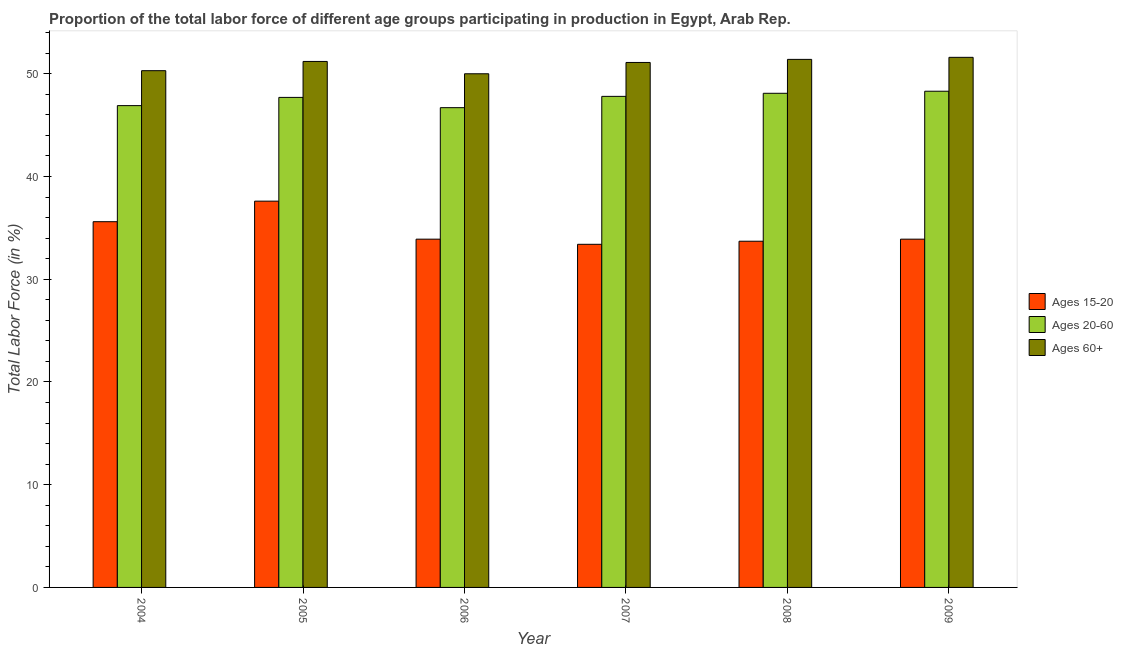How many different coloured bars are there?
Offer a very short reply. 3. How many groups of bars are there?
Your answer should be compact. 6. What is the label of the 2nd group of bars from the left?
Your answer should be very brief. 2005. What is the percentage of labor force above age 60 in 2009?
Your answer should be very brief. 51.6. Across all years, what is the maximum percentage of labor force above age 60?
Your answer should be very brief. 51.6. Across all years, what is the minimum percentage of labor force within the age group 15-20?
Your answer should be very brief. 33.4. What is the total percentage of labor force within the age group 20-60 in the graph?
Your response must be concise. 285.5. What is the difference between the percentage of labor force within the age group 20-60 in 2004 and that in 2008?
Provide a succinct answer. -1.2. What is the average percentage of labor force within the age group 20-60 per year?
Offer a terse response. 47.58. What is the ratio of the percentage of labor force above age 60 in 2008 to that in 2009?
Provide a succinct answer. 1. Is the percentage of labor force above age 60 in 2007 less than that in 2008?
Ensure brevity in your answer.  Yes. Is the difference between the percentage of labor force within the age group 15-20 in 2004 and 2005 greater than the difference between the percentage of labor force within the age group 20-60 in 2004 and 2005?
Your response must be concise. No. What is the difference between the highest and the lowest percentage of labor force within the age group 20-60?
Give a very brief answer. 1.6. In how many years, is the percentage of labor force within the age group 15-20 greater than the average percentage of labor force within the age group 15-20 taken over all years?
Your answer should be very brief. 2. What does the 1st bar from the left in 2004 represents?
Give a very brief answer. Ages 15-20. What does the 2nd bar from the right in 2009 represents?
Provide a short and direct response. Ages 20-60. Is it the case that in every year, the sum of the percentage of labor force within the age group 15-20 and percentage of labor force within the age group 20-60 is greater than the percentage of labor force above age 60?
Keep it short and to the point. Yes. What is the difference between two consecutive major ticks on the Y-axis?
Ensure brevity in your answer.  10. Are the values on the major ticks of Y-axis written in scientific E-notation?
Ensure brevity in your answer.  No. Does the graph contain any zero values?
Provide a succinct answer. No. Does the graph contain grids?
Give a very brief answer. No. Where does the legend appear in the graph?
Your answer should be very brief. Center right. How many legend labels are there?
Make the answer very short. 3. How are the legend labels stacked?
Your answer should be compact. Vertical. What is the title of the graph?
Offer a terse response. Proportion of the total labor force of different age groups participating in production in Egypt, Arab Rep. Does "Solid fuel" appear as one of the legend labels in the graph?
Give a very brief answer. No. What is the label or title of the X-axis?
Your answer should be very brief. Year. What is the Total Labor Force (in %) of Ages 15-20 in 2004?
Offer a very short reply. 35.6. What is the Total Labor Force (in %) in Ages 20-60 in 2004?
Offer a very short reply. 46.9. What is the Total Labor Force (in %) of Ages 60+ in 2004?
Offer a terse response. 50.3. What is the Total Labor Force (in %) of Ages 15-20 in 2005?
Your response must be concise. 37.6. What is the Total Labor Force (in %) in Ages 20-60 in 2005?
Make the answer very short. 47.7. What is the Total Labor Force (in %) in Ages 60+ in 2005?
Offer a terse response. 51.2. What is the Total Labor Force (in %) in Ages 15-20 in 2006?
Offer a terse response. 33.9. What is the Total Labor Force (in %) of Ages 20-60 in 2006?
Ensure brevity in your answer.  46.7. What is the Total Labor Force (in %) of Ages 15-20 in 2007?
Provide a short and direct response. 33.4. What is the Total Labor Force (in %) in Ages 20-60 in 2007?
Provide a succinct answer. 47.8. What is the Total Labor Force (in %) in Ages 60+ in 2007?
Offer a very short reply. 51.1. What is the Total Labor Force (in %) in Ages 15-20 in 2008?
Give a very brief answer. 33.7. What is the Total Labor Force (in %) in Ages 20-60 in 2008?
Your response must be concise. 48.1. What is the Total Labor Force (in %) in Ages 60+ in 2008?
Provide a short and direct response. 51.4. What is the Total Labor Force (in %) of Ages 15-20 in 2009?
Make the answer very short. 33.9. What is the Total Labor Force (in %) in Ages 20-60 in 2009?
Offer a terse response. 48.3. What is the Total Labor Force (in %) in Ages 60+ in 2009?
Provide a succinct answer. 51.6. Across all years, what is the maximum Total Labor Force (in %) of Ages 15-20?
Offer a very short reply. 37.6. Across all years, what is the maximum Total Labor Force (in %) in Ages 20-60?
Give a very brief answer. 48.3. Across all years, what is the maximum Total Labor Force (in %) of Ages 60+?
Your answer should be very brief. 51.6. Across all years, what is the minimum Total Labor Force (in %) in Ages 15-20?
Ensure brevity in your answer.  33.4. Across all years, what is the minimum Total Labor Force (in %) of Ages 20-60?
Provide a short and direct response. 46.7. Across all years, what is the minimum Total Labor Force (in %) of Ages 60+?
Your answer should be very brief. 50. What is the total Total Labor Force (in %) in Ages 15-20 in the graph?
Your answer should be compact. 208.1. What is the total Total Labor Force (in %) in Ages 20-60 in the graph?
Your response must be concise. 285.5. What is the total Total Labor Force (in %) of Ages 60+ in the graph?
Your response must be concise. 305.6. What is the difference between the Total Labor Force (in %) in Ages 15-20 in 2004 and that in 2005?
Your answer should be compact. -2. What is the difference between the Total Labor Force (in %) of Ages 60+ in 2004 and that in 2006?
Your response must be concise. 0.3. What is the difference between the Total Labor Force (in %) of Ages 20-60 in 2004 and that in 2007?
Your answer should be very brief. -0.9. What is the difference between the Total Labor Force (in %) in Ages 60+ in 2004 and that in 2008?
Offer a very short reply. -1.1. What is the difference between the Total Labor Force (in %) in Ages 15-20 in 2004 and that in 2009?
Your response must be concise. 1.7. What is the difference between the Total Labor Force (in %) in Ages 20-60 in 2004 and that in 2009?
Offer a terse response. -1.4. What is the difference between the Total Labor Force (in %) in Ages 20-60 in 2005 and that in 2006?
Provide a succinct answer. 1. What is the difference between the Total Labor Force (in %) in Ages 60+ in 2005 and that in 2006?
Your answer should be compact. 1.2. What is the difference between the Total Labor Force (in %) in Ages 15-20 in 2005 and that in 2007?
Ensure brevity in your answer.  4.2. What is the difference between the Total Labor Force (in %) in Ages 20-60 in 2005 and that in 2008?
Give a very brief answer. -0.4. What is the difference between the Total Labor Force (in %) in Ages 15-20 in 2006 and that in 2008?
Offer a terse response. 0.2. What is the difference between the Total Labor Force (in %) of Ages 60+ in 2006 and that in 2008?
Offer a terse response. -1.4. What is the difference between the Total Labor Force (in %) in Ages 15-20 in 2006 and that in 2009?
Keep it short and to the point. 0. What is the difference between the Total Labor Force (in %) in Ages 20-60 in 2007 and that in 2009?
Your answer should be very brief. -0.5. What is the difference between the Total Labor Force (in %) of Ages 15-20 in 2008 and that in 2009?
Your response must be concise. -0.2. What is the difference between the Total Labor Force (in %) in Ages 15-20 in 2004 and the Total Labor Force (in %) in Ages 20-60 in 2005?
Keep it short and to the point. -12.1. What is the difference between the Total Labor Force (in %) in Ages 15-20 in 2004 and the Total Labor Force (in %) in Ages 60+ in 2005?
Offer a terse response. -15.6. What is the difference between the Total Labor Force (in %) in Ages 20-60 in 2004 and the Total Labor Force (in %) in Ages 60+ in 2005?
Offer a very short reply. -4.3. What is the difference between the Total Labor Force (in %) in Ages 15-20 in 2004 and the Total Labor Force (in %) in Ages 60+ in 2006?
Keep it short and to the point. -14.4. What is the difference between the Total Labor Force (in %) in Ages 20-60 in 2004 and the Total Labor Force (in %) in Ages 60+ in 2006?
Ensure brevity in your answer.  -3.1. What is the difference between the Total Labor Force (in %) in Ages 15-20 in 2004 and the Total Labor Force (in %) in Ages 20-60 in 2007?
Ensure brevity in your answer.  -12.2. What is the difference between the Total Labor Force (in %) of Ages 15-20 in 2004 and the Total Labor Force (in %) of Ages 60+ in 2007?
Provide a short and direct response. -15.5. What is the difference between the Total Labor Force (in %) in Ages 20-60 in 2004 and the Total Labor Force (in %) in Ages 60+ in 2007?
Provide a succinct answer. -4.2. What is the difference between the Total Labor Force (in %) of Ages 15-20 in 2004 and the Total Labor Force (in %) of Ages 60+ in 2008?
Make the answer very short. -15.8. What is the difference between the Total Labor Force (in %) of Ages 15-20 in 2004 and the Total Labor Force (in %) of Ages 60+ in 2009?
Provide a short and direct response. -16. What is the difference between the Total Labor Force (in %) of Ages 20-60 in 2004 and the Total Labor Force (in %) of Ages 60+ in 2009?
Provide a succinct answer. -4.7. What is the difference between the Total Labor Force (in %) of Ages 20-60 in 2005 and the Total Labor Force (in %) of Ages 60+ in 2006?
Provide a short and direct response. -2.3. What is the difference between the Total Labor Force (in %) of Ages 15-20 in 2005 and the Total Labor Force (in %) of Ages 60+ in 2007?
Ensure brevity in your answer.  -13.5. What is the difference between the Total Labor Force (in %) in Ages 20-60 in 2005 and the Total Labor Force (in %) in Ages 60+ in 2007?
Offer a terse response. -3.4. What is the difference between the Total Labor Force (in %) of Ages 15-20 in 2005 and the Total Labor Force (in %) of Ages 20-60 in 2009?
Your response must be concise. -10.7. What is the difference between the Total Labor Force (in %) of Ages 15-20 in 2006 and the Total Labor Force (in %) of Ages 20-60 in 2007?
Offer a terse response. -13.9. What is the difference between the Total Labor Force (in %) in Ages 15-20 in 2006 and the Total Labor Force (in %) in Ages 60+ in 2007?
Your response must be concise. -17.2. What is the difference between the Total Labor Force (in %) in Ages 20-60 in 2006 and the Total Labor Force (in %) in Ages 60+ in 2007?
Your answer should be compact. -4.4. What is the difference between the Total Labor Force (in %) of Ages 15-20 in 2006 and the Total Labor Force (in %) of Ages 20-60 in 2008?
Make the answer very short. -14.2. What is the difference between the Total Labor Force (in %) of Ages 15-20 in 2006 and the Total Labor Force (in %) of Ages 60+ in 2008?
Make the answer very short. -17.5. What is the difference between the Total Labor Force (in %) in Ages 20-60 in 2006 and the Total Labor Force (in %) in Ages 60+ in 2008?
Offer a very short reply. -4.7. What is the difference between the Total Labor Force (in %) of Ages 15-20 in 2006 and the Total Labor Force (in %) of Ages 20-60 in 2009?
Keep it short and to the point. -14.4. What is the difference between the Total Labor Force (in %) of Ages 15-20 in 2006 and the Total Labor Force (in %) of Ages 60+ in 2009?
Offer a terse response. -17.7. What is the difference between the Total Labor Force (in %) of Ages 15-20 in 2007 and the Total Labor Force (in %) of Ages 20-60 in 2008?
Your response must be concise. -14.7. What is the difference between the Total Labor Force (in %) in Ages 15-20 in 2007 and the Total Labor Force (in %) in Ages 60+ in 2008?
Give a very brief answer. -18. What is the difference between the Total Labor Force (in %) in Ages 15-20 in 2007 and the Total Labor Force (in %) in Ages 20-60 in 2009?
Provide a succinct answer. -14.9. What is the difference between the Total Labor Force (in %) in Ages 15-20 in 2007 and the Total Labor Force (in %) in Ages 60+ in 2009?
Provide a succinct answer. -18.2. What is the difference between the Total Labor Force (in %) of Ages 15-20 in 2008 and the Total Labor Force (in %) of Ages 20-60 in 2009?
Ensure brevity in your answer.  -14.6. What is the difference between the Total Labor Force (in %) in Ages 15-20 in 2008 and the Total Labor Force (in %) in Ages 60+ in 2009?
Give a very brief answer. -17.9. What is the average Total Labor Force (in %) of Ages 15-20 per year?
Keep it short and to the point. 34.68. What is the average Total Labor Force (in %) of Ages 20-60 per year?
Make the answer very short. 47.58. What is the average Total Labor Force (in %) in Ages 60+ per year?
Make the answer very short. 50.93. In the year 2004, what is the difference between the Total Labor Force (in %) of Ages 15-20 and Total Labor Force (in %) of Ages 60+?
Offer a terse response. -14.7. In the year 2004, what is the difference between the Total Labor Force (in %) of Ages 20-60 and Total Labor Force (in %) of Ages 60+?
Your answer should be compact. -3.4. In the year 2005, what is the difference between the Total Labor Force (in %) of Ages 20-60 and Total Labor Force (in %) of Ages 60+?
Make the answer very short. -3.5. In the year 2006, what is the difference between the Total Labor Force (in %) in Ages 15-20 and Total Labor Force (in %) in Ages 60+?
Provide a succinct answer. -16.1. In the year 2006, what is the difference between the Total Labor Force (in %) in Ages 20-60 and Total Labor Force (in %) in Ages 60+?
Ensure brevity in your answer.  -3.3. In the year 2007, what is the difference between the Total Labor Force (in %) of Ages 15-20 and Total Labor Force (in %) of Ages 20-60?
Provide a succinct answer. -14.4. In the year 2007, what is the difference between the Total Labor Force (in %) in Ages 15-20 and Total Labor Force (in %) in Ages 60+?
Provide a short and direct response. -17.7. In the year 2008, what is the difference between the Total Labor Force (in %) of Ages 15-20 and Total Labor Force (in %) of Ages 20-60?
Provide a short and direct response. -14.4. In the year 2008, what is the difference between the Total Labor Force (in %) of Ages 15-20 and Total Labor Force (in %) of Ages 60+?
Your answer should be compact. -17.7. In the year 2008, what is the difference between the Total Labor Force (in %) in Ages 20-60 and Total Labor Force (in %) in Ages 60+?
Give a very brief answer. -3.3. In the year 2009, what is the difference between the Total Labor Force (in %) in Ages 15-20 and Total Labor Force (in %) in Ages 20-60?
Your answer should be compact. -14.4. In the year 2009, what is the difference between the Total Labor Force (in %) of Ages 15-20 and Total Labor Force (in %) of Ages 60+?
Offer a terse response. -17.7. In the year 2009, what is the difference between the Total Labor Force (in %) of Ages 20-60 and Total Labor Force (in %) of Ages 60+?
Your response must be concise. -3.3. What is the ratio of the Total Labor Force (in %) in Ages 15-20 in 2004 to that in 2005?
Your answer should be very brief. 0.95. What is the ratio of the Total Labor Force (in %) of Ages 20-60 in 2004 to that in 2005?
Offer a very short reply. 0.98. What is the ratio of the Total Labor Force (in %) of Ages 60+ in 2004 to that in 2005?
Make the answer very short. 0.98. What is the ratio of the Total Labor Force (in %) in Ages 15-20 in 2004 to that in 2006?
Your answer should be very brief. 1.05. What is the ratio of the Total Labor Force (in %) of Ages 60+ in 2004 to that in 2006?
Provide a succinct answer. 1.01. What is the ratio of the Total Labor Force (in %) of Ages 15-20 in 2004 to that in 2007?
Make the answer very short. 1.07. What is the ratio of the Total Labor Force (in %) in Ages 20-60 in 2004 to that in 2007?
Ensure brevity in your answer.  0.98. What is the ratio of the Total Labor Force (in %) of Ages 60+ in 2004 to that in 2007?
Give a very brief answer. 0.98. What is the ratio of the Total Labor Force (in %) of Ages 15-20 in 2004 to that in 2008?
Give a very brief answer. 1.06. What is the ratio of the Total Labor Force (in %) of Ages 20-60 in 2004 to that in 2008?
Give a very brief answer. 0.98. What is the ratio of the Total Labor Force (in %) of Ages 60+ in 2004 to that in 2008?
Offer a terse response. 0.98. What is the ratio of the Total Labor Force (in %) in Ages 15-20 in 2004 to that in 2009?
Your answer should be very brief. 1.05. What is the ratio of the Total Labor Force (in %) in Ages 20-60 in 2004 to that in 2009?
Your answer should be compact. 0.97. What is the ratio of the Total Labor Force (in %) in Ages 60+ in 2004 to that in 2009?
Offer a terse response. 0.97. What is the ratio of the Total Labor Force (in %) of Ages 15-20 in 2005 to that in 2006?
Provide a succinct answer. 1.11. What is the ratio of the Total Labor Force (in %) of Ages 20-60 in 2005 to that in 2006?
Give a very brief answer. 1.02. What is the ratio of the Total Labor Force (in %) of Ages 15-20 in 2005 to that in 2007?
Keep it short and to the point. 1.13. What is the ratio of the Total Labor Force (in %) in Ages 20-60 in 2005 to that in 2007?
Give a very brief answer. 1. What is the ratio of the Total Labor Force (in %) in Ages 15-20 in 2005 to that in 2008?
Your response must be concise. 1.12. What is the ratio of the Total Labor Force (in %) of Ages 20-60 in 2005 to that in 2008?
Ensure brevity in your answer.  0.99. What is the ratio of the Total Labor Force (in %) of Ages 60+ in 2005 to that in 2008?
Your answer should be very brief. 1. What is the ratio of the Total Labor Force (in %) of Ages 15-20 in 2005 to that in 2009?
Your answer should be compact. 1.11. What is the ratio of the Total Labor Force (in %) in Ages 20-60 in 2005 to that in 2009?
Make the answer very short. 0.99. What is the ratio of the Total Labor Force (in %) of Ages 15-20 in 2006 to that in 2007?
Offer a very short reply. 1.01. What is the ratio of the Total Labor Force (in %) of Ages 20-60 in 2006 to that in 2007?
Provide a succinct answer. 0.98. What is the ratio of the Total Labor Force (in %) of Ages 60+ in 2006 to that in 2007?
Provide a short and direct response. 0.98. What is the ratio of the Total Labor Force (in %) of Ages 15-20 in 2006 to that in 2008?
Your answer should be very brief. 1.01. What is the ratio of the Total Labor Force (in %) in Ages 20-60 in 2006 to that in 2008?
Make the answer very short. 0.97. What is the ratio of the Total Labor Force (in %) in Ages 60+ in 2006 to that in 2008?
Provide a succinct answer. 0.97. What is the ratio of the Total Labor Force (in %) in Ages 20-60 in 2006 to that in 2009?
Keep it short and to the point. 0.97. What is the ratio of the Total Labor Force (in %) of Ages 15-20 in 2007 to that in 2008?
Offer a terse response. 0.99. What is the ratio of the Total Labor Force (in %) in Ages 60+ in 2007 to that in 2009?
Keep it short and to the point. 0.99. What is the difference between the highest and the second highest Total Labor Force (in %) of Ages 60+?
Ensure brevity in your answer.  0.2. What is the difference between the highest and the lowest Total Labor Force (in %) in Ages 20-60?
Offer a very short reply. 1.6. 